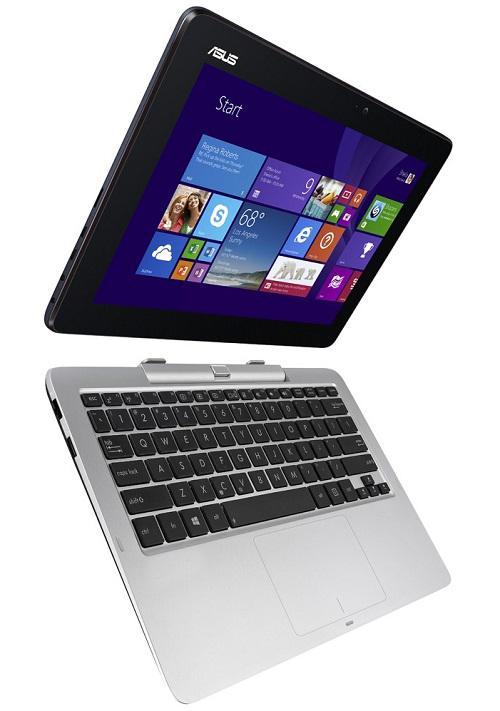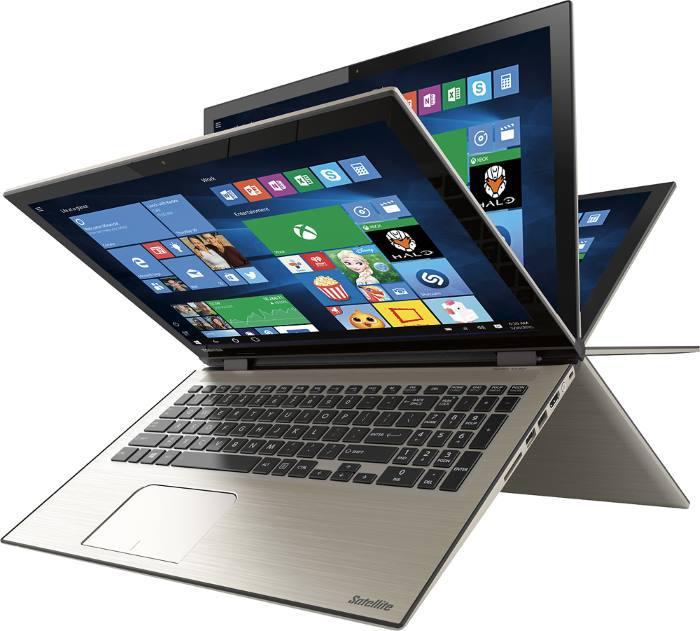The first image is the image on the left, the second image is the image on the right. For the images displayed, is the sentence "The left image shows a keyboard base separated from the screen, and the right image shows a device with multiple fanned out screens on top of an inverted V base." factually correct? Answer yes or no. Yes. The first image is the image on the left, the second image is the image on the right. Given the left and right images, does the statement "The laptop in the image on the right is shown opening is several positions." hold true? Answer yes or no. Yes. 